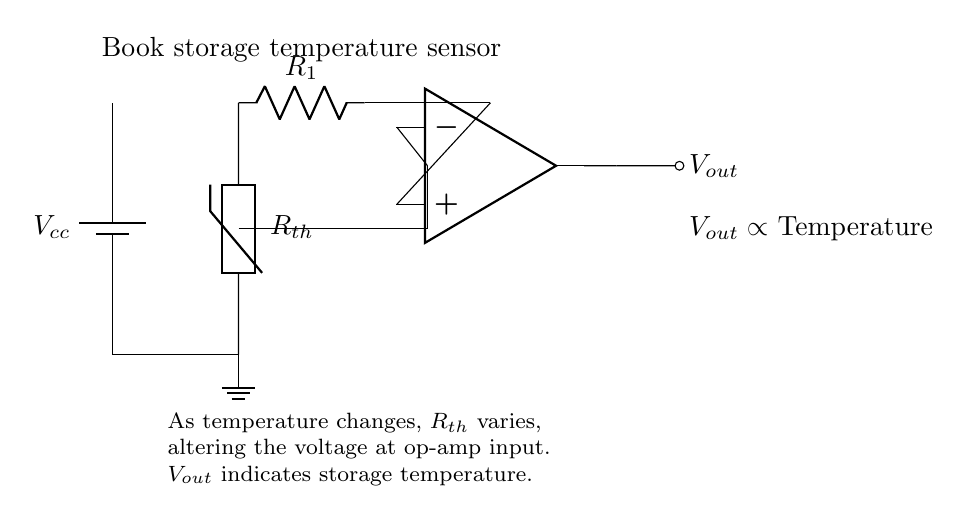What is the type of temperature sensor used in this circuit? The circuit uses a thermistor as the temperature sensor. This is indicated by the symbol labeled Rth in the diagram.
Answer: thermistor What is the output voltage proportional to? The output voltage Vout is proportional to the temperature being measured, as stated in the explanation provided in the circuit diagram.
Answer: Temperature What is the purpose of the resistor R1 in this circuit? Resistor R1, in conjunction with the thermistor, forms a voltage divider. This setup helps to convert the changing resistance of the thermistor into a varying voltage signal to be processed by the op-amp.
Answer: Voltage divider How does an increase in temperature affect the thermistor behavior? An increase in temperature typically decreases the resistance of a thermistor. This may cause a rise in the voltage input to the op-amp, leading to a higher output voltage.
Answer: Decrease resistance What is the role of the operational amplifier in this circuit? The operational amplifier amplifies the voltage signal derived from the thermistor and resistor combination, producing a readable output voltage that reflects the temperature level.
Answer: Amplifier What type of circuit configuration is depicted in this diagram? The diagram depicts an analog circuit configuration dedicated to monitoring temperature conditions, utilizing continuous signals as opposed to discrete ones.
Answer: Analog circuit What happens to the output Vout as the temperature rises? As the temperature rises, the output voltage Vout increases proportionally, indicating a higher voltage level to represent an increase in temperature in the book storage environment.
Answer: Increases 